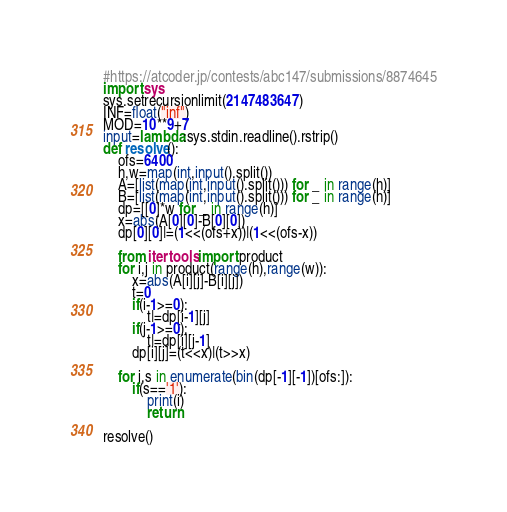Convert code to text. <code><loc_0><loc_0><loc_500><loc_500><_Python_>#https://atcoder.jp/contests/abc147/submissions/8874645
import sys
sys.setrecursionlimit(2147483647)
INF=float("inf")
MOD=10**9+7
input=lambda:sys.stdin.readline().rstrip()
def resolve():
    ofs=6400
    h,w=map(int,input().split())
    A=[list(map(int,input().split())) for _ in range(h)]
    B=[list(map(int,input().split())) for _ in range(h)]
    dp=[[0]*w for _ in range(h)]
    x=abs(A[0][0]-B[0][0])
    dp[0][0]|=(1<<(ofs+x))|(1<<(ofs-x))

    from itertools import product
    for i,j in product(range(h),range(w)):
        x=abs(A[i][j]-B[i][j])
        t=0
        if(i-1>=0):
            t|=dp[i-1][j]
        if(j-1>=0):
            t|=dp[i][j-1]
        dp[i][j]=(t<<x)|(t>>x)

    for i,s in enumerate(bin(dp[-1][-1])[ofs:]):
        if(s=='1'):
            print(i)
            return
                    
resolve()
</code> 